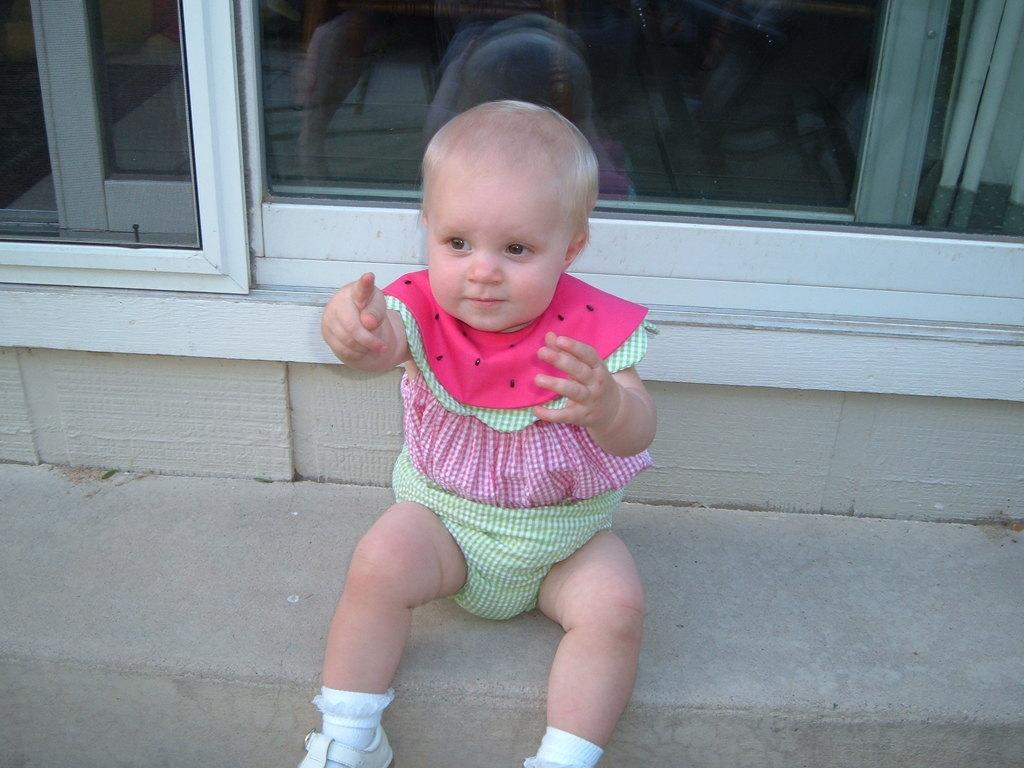What is the main subject of the image? There is a child in the image. Can you describe the child's clothing? The child is wearing a dress with green, pink, and white colors. What can be seen in the background of the image? There are glass doors in the background of the image. Can you hear the child whistling in the image? There is no indication of sound in the image, so it cannot be determined if the child is whistling. 